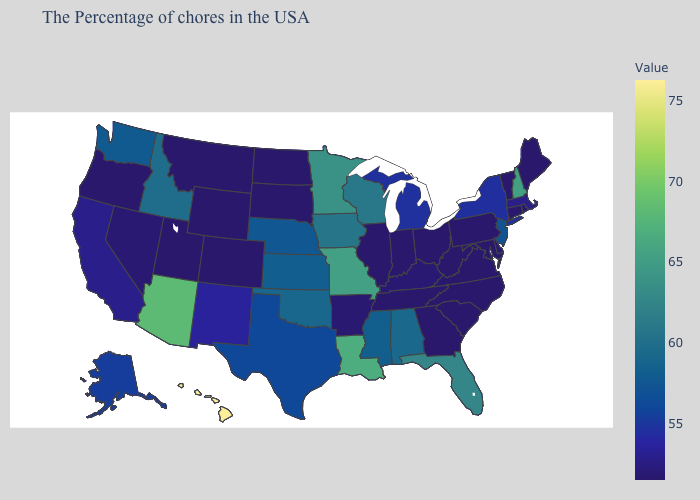Among the states that border Oklahoma , does Colorado have the highest value?
Concise answer only. No. Which states have the lowest value in the USA?
Keep it brief. Maine, Rhode Island, Vermont, Connecticut, Maryland, Pennsylvania, Virginia, North Carolina, South Carolina, West Virginia, Ohio, Georgia, Indiana, Tennessee, Illinois, South Dakota, North Dakota, Wyoming, Colorado, Utah, Montana, Oregon. Is the legend a continuous bar?
Give a very brief answer. Yes. Does Pennsylvania have the lowest value in the Northeast?
Keep it brief. Yes. Among the states that border Nebraska , does Iowa have the lowest value?
Short answer required. No. 